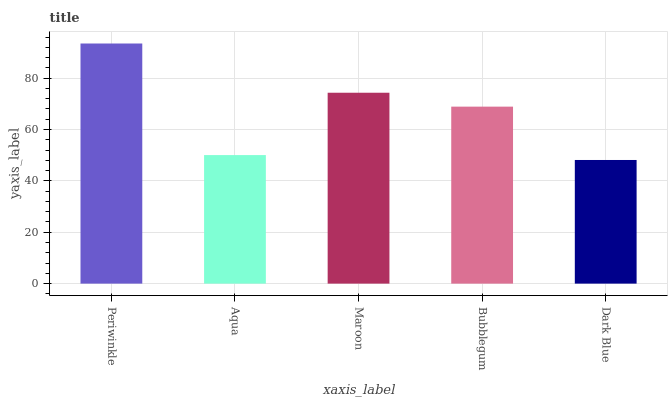Is Dark Blue the minimum?
Answer yes or no. Yes. Is Periwinkle the maximum?
Answer yes or no. Yes. Is Aqua the minimum?
Answer yes or no. No. Is Aqua the maximum?
Answer yes or no. No. Is Periwinkle greater than Aqua?
Answer yes or no. Yes. Is Aqua less than Periwinkle?
Answer yes or no. Yes. Is Aqua greater than Periwinkle?
Answer yes or no. No. Is Periwinkle less than Aqua?
Answer yes or no. No. Is Bubblegum the high median?
Answer yes or no. Yes. Is Bubblegum the low median?
Answer yes or no. Yes. Is Periwinkle the high median?
Answer yes or no. No. Is Maroon the low median?
Answer yes or no. No. 